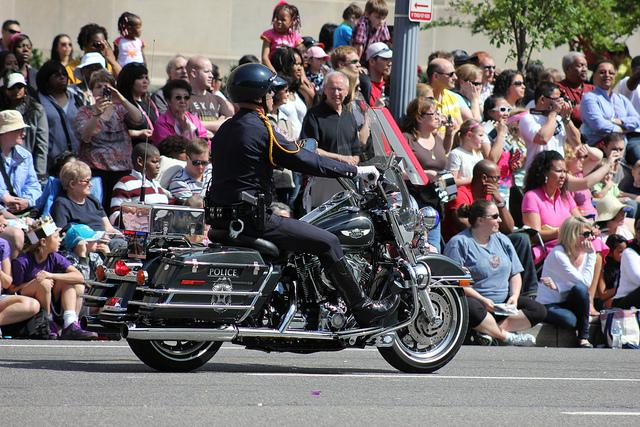Why is the crown worn here?

Choices:
A) he's royalty
B) heir apparent
C) for fun
D) imposter for fun 